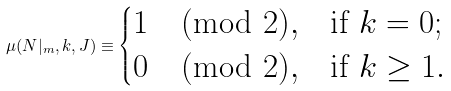<formula> <loc_0><loc_0><loc_500><loc_500>\mu ( N | _ { m } , k , J ) \equiv \begin{cases} 1 \pmod { 2 } , & \text {if $k=0$} ; \\ 0 \pmod { 2 } , & \text {if $k\geq 1$} . \\ \end{cases}</formula> 